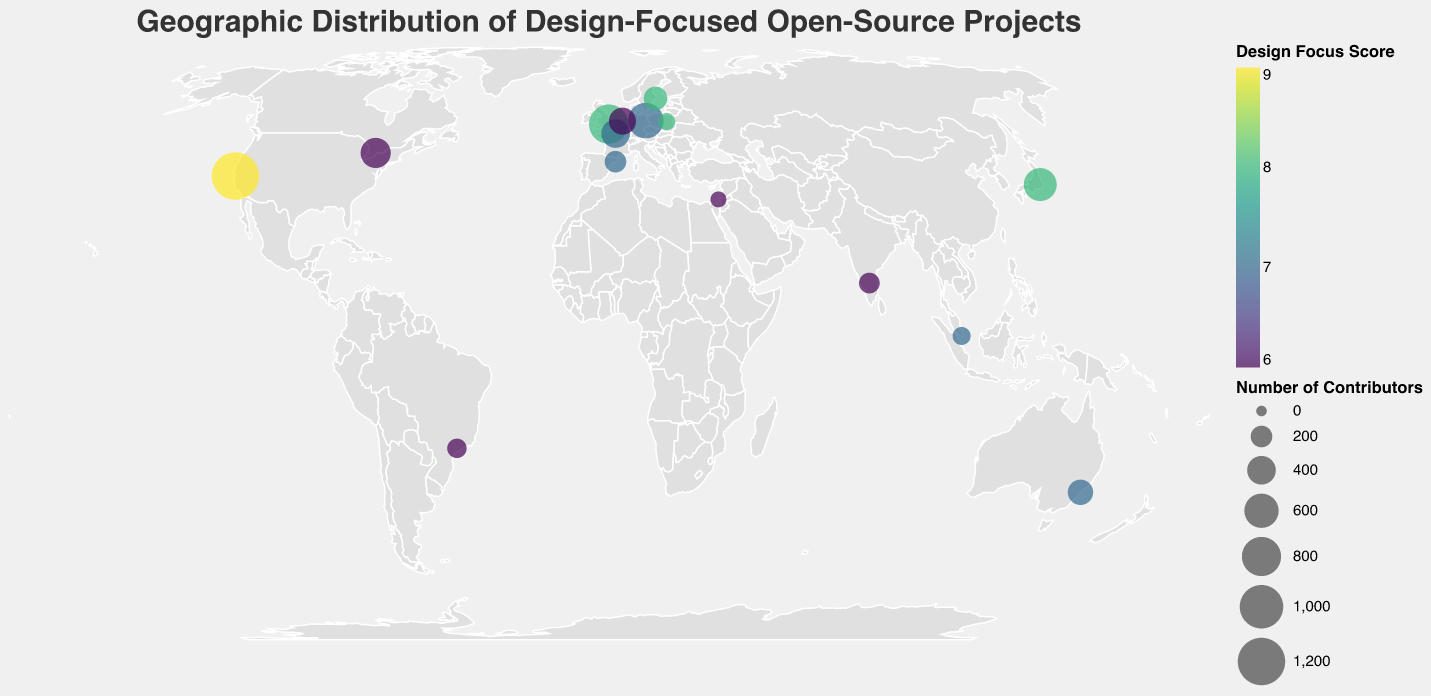How many cities are represented on the map? The visual shows dots on various cities across the world. Counting these dots will give the number of cities represented.
Answer: 15 Which project has the highest number of contributors, and where is it located? By examining the size of the circles, the largest circle represents the project with the most contributors. From the tooltip, we can identify that Bootstrap in San Francisco has the highest number of contributors.
Answer: Bootstrap in San Francisco What is the average Design Focus Score for projects in Europe? To find the average, we need the Design Focus Scores of the projects in European cities: London (8), Berlin (7), Paris (7), Amsterdam (6), Warsaw (8). Sum these scores and divide by the number of cities: (8 + 7 + 7 + 6 + 8) / 5 = 36 / 5.
Answer: 7.2 Which geographic region (continent) has the highest concentration of design-focused open-source projects? By observing the distribution of the circles on the map, we count and compare the number of projects in different continents. Europe has the most circles, indicating the highest concentration.
Answer: Europe Compare the contributors from Bootstrap and Tailwind CSS. How many more contributors does Bootstrap have than Tailwind CSS? Bootstrap has 1200 contributors and Tailwind CSS has 800 contributors. The difference in contributors is calculated as 1200 - 800.
Answer: 400 What is the significance of different circle sizes and colors on the geographic plot? The size of the circles represents the number of contributors; larger circles indicate more contributors. The color represents the Design Focus Score, with different shades indicating various scores.
Answer: Circle size: Number of contributors; Circle color: Design Focus Score Which city outside of Europe has the highest Design Focus Score, and what is that score? Checking the tooltip for non-European cities, Tokyo has the highest Design Focus Score of 8.
Answer: Tokyo, 8 What color scheme is used to represent the Design Focus Score, and what is its significance? The color scheme used is "viridis," a perceptually uniform colormap that makes it easier to distinguish different scores. Darker colors typically represent higher scores.
Answer: Viridis, darker colors indicate higher scores What are the top three cities with the highest number of contributors? Observing the circle sizes and tooltips: San Francisco (1200), London (800), Berlin (650).
Answer: San Francisco, London, Berlin 